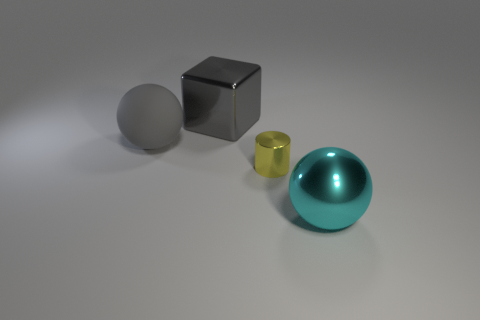Add 2 brown matte cylinders. How many objects exist? 6 Subtract all cyan balls. How many balls are left? 1 Subtract all brown blocks. How many cyan balls are left? 1 Subtract all tiny green rubber cylinders. Subtract all small cylinders. How many objects are left? 3 Add 4 big objects. How many big objects are left? 7 Add 3 small yellow metallic objects. How many small yellow metallic objects exist? 4 Subtract 0 blue spheres. How many objects are left? 4 Subtract all cylinders. How many objects are left? 3 Subtract all red cylinders. Subtract all brown blocks. How many cylinders are left? 1 